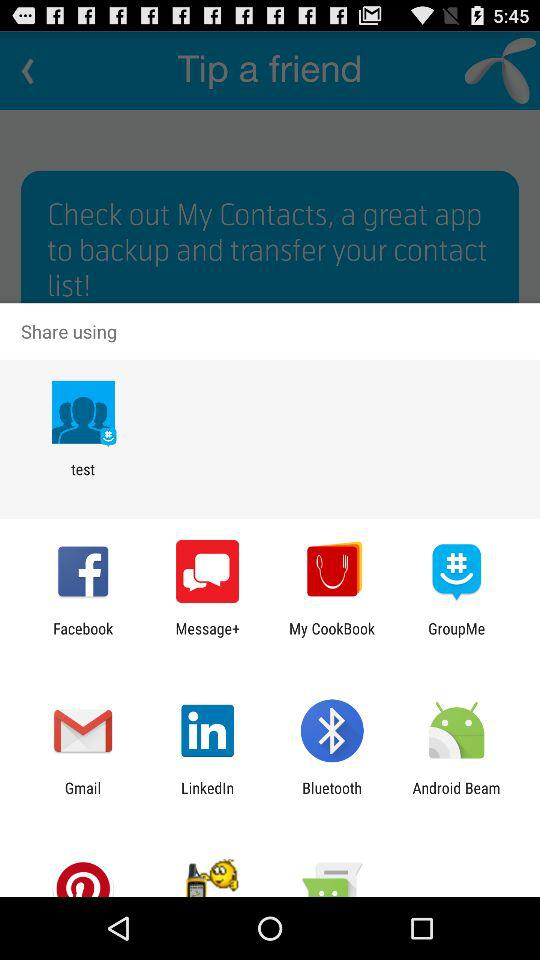Through what applications can content be shared? Content can be shared through "test", "Facebook", "Message+", "My CookBook", "GroupMe", "Gmail", "LinkedIn", "Bluetooth" and "Android Beam". 